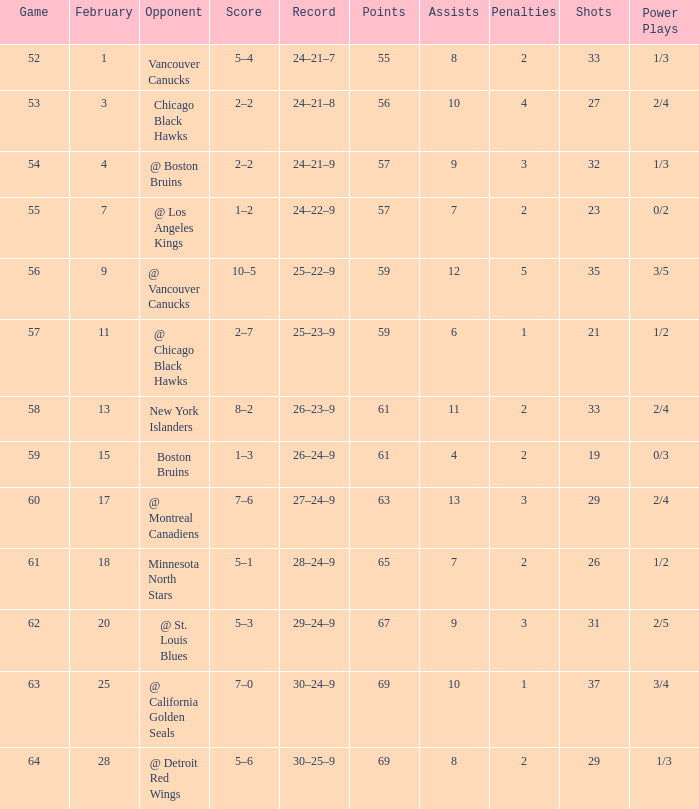How many february games had a record of 29–24–9? 20.0. 